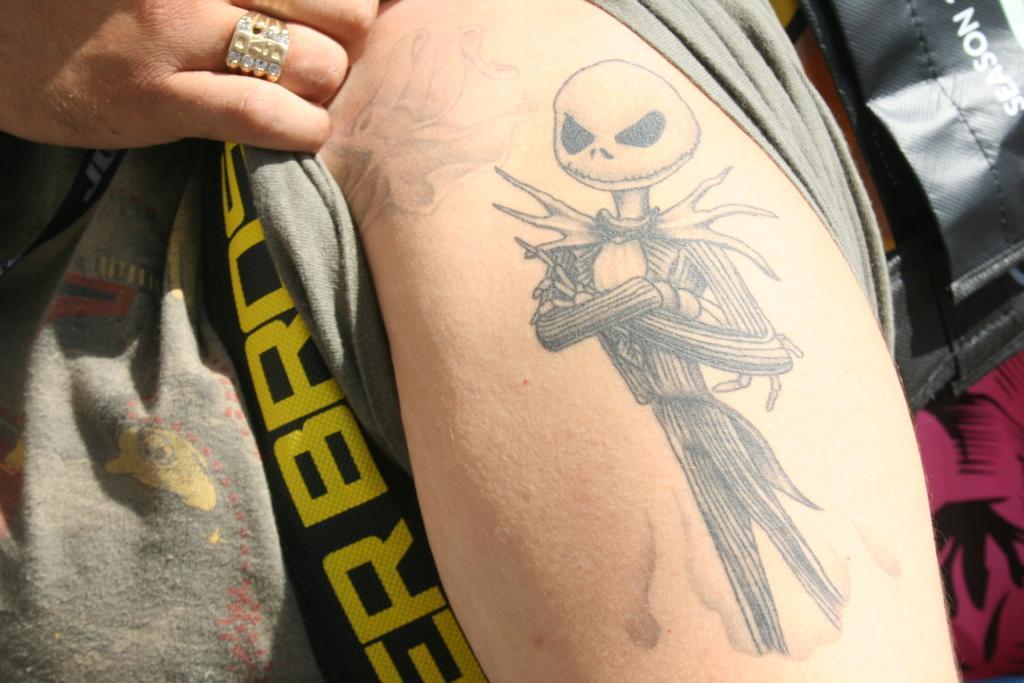Please provide a concise description of this image. In this image I can see a person's hand, fingers, ring and objects. On a person's hand there is a tattoo. 